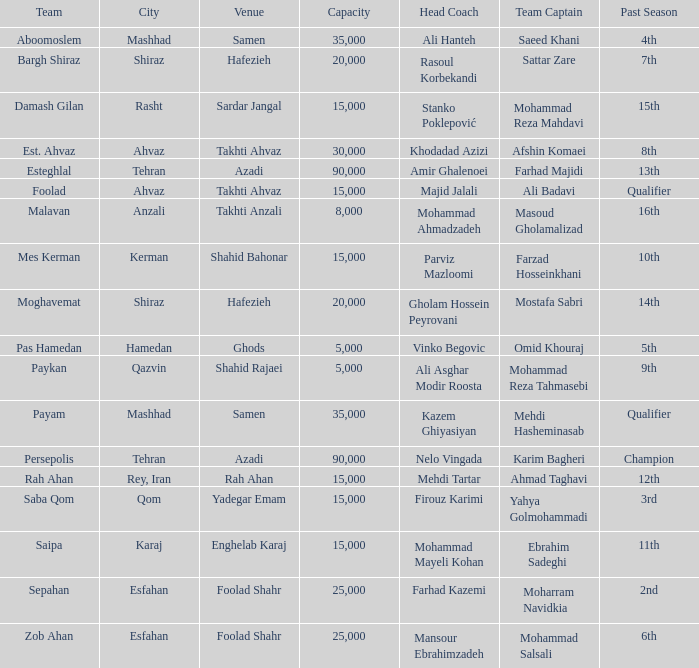What Venue has a Past Season of 2nd? Foolad Shahr. Write the full table. {'header': ['Team', 'City', 'Venue', 'Capacity', 'Head Coach', 'Team Captain', 'Past Season'], 'rows': [['Aboomoslem', 'Mashhad', 'Samen', '35,000', 'Ali Hanteh', 'Saeed Khani', '4th'], ['Bargh Shiraz', 'Shiraz', 'Hafezieh', '20,000', 'Rasoul Korbekandi', 'Sattar Zare', '7th'], ['Damash Gilan', 'Rasht', 'Sardar Jangal', '15,000', 'Stanko Poklepović', 'Mohammad Reza Mahdavi', '15th'], ['Est. Ahvaz', 'Ahvaz', 'Takhti Ahvaz', '30,000', 'Khodadad Azizi', 'Afshin Komaei', '8th'], ['Esteghlal', 'Tehran', 'Azadi', '90,000', 'Amir Ghalenoei', 'Farhad Majidi', '13th'], ['Foolad', 'Ahvaz', 'Takhti Ahvaz', '15,000', 'Majid Jalali', 'Ali Badavi', 'Qualifier'], ['Malavan', 'Anzali', 'Takhti Anzali', '8,000', 'Mohammad Ahmadzadeh', 'Masoud Gholamalizad', '16th'], ['Mes Kerman', 'Kerman', 'Shahid Bahonar', '15,000', 'Parviz Mazloomi', 'Farzad Hosseinkhani', '10th'], ['Moghavemat', 'Shiraz', 'Hafezieh', '20,000', 'Gholam Hossein Peyrovani', 'Mostafa Sabri', '14th'], ['Pas Hamedan', 'Hamedan', 'Ghods', '5,000', 'Vinko Begovic', 'Omid Khouraj', '5th'], ['Paykan', 'Qazvin', 'Shahid Rajaei', '5,000', 'Ali Asghar Modir Roosta', 'Mohammad Reza Tahmasebi', '9th'], ['Payam', 'Mashhad', 'Samen', '35,000', 'Kazem Ghiyasiyan', 'Mehdi Hasheminasab', 'Qualifier'], ['Persepolis', 'Tehran', 'Azadi', '90,000', 'Nelo Vingada', 'Karim Bagheri', 'Champion'], ['Rah Ahan', 'Rey, Iran', 'Rah Ahan', '15,000', 'Mehdi Tartar', 'Ahmad Taghavi', '12th'], ['Saba Qom', 'Qom', 'Yadegar Emam', '15,000', 'Firouz Karimi', 'Yahya Golmohammadi', '3rd'], ['Saipa', 'Karaj', 'Enghelab Karaj', '15,000', 'Mohammad Mayeli Kohan', 'Ebrahim Sadeghi', '11th'], ['Sepahan', 'Esfahan', 'Foolad Shahr', '25,000', 'Farhad Kazemi', 'Moharram Navidkia', '2nd'], ['Zob Ahan', 'Esfahan', 'Foolad Shahr', '25,000', 'Mansour Ebrahimzadeh', 'Mohammad Salsali', '6th']]} 